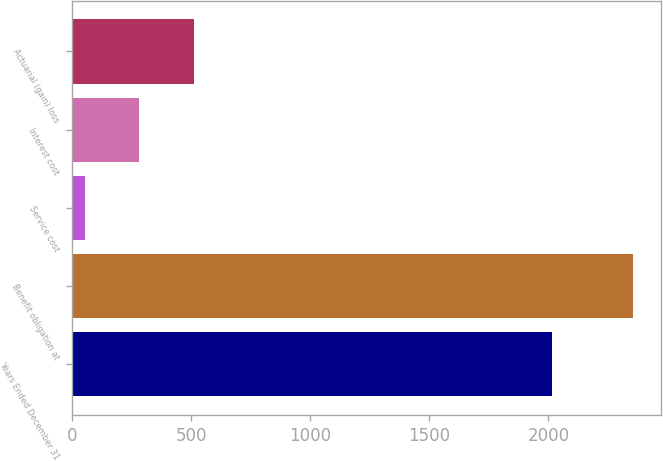Convert chart to OTSL. <chart><loc_0><loc_0><loc_500><loc_500><bar_chart><fcel>Years Ended December 31<fcel>Benefit obligation at<fcel>Service cost<fcel>Interest cost<fcel>Actuarial (gain) loss<nl><fcel>2013<fcel>2354<fcel>53<fcel>283.1<fcel>513.2<nl></chart> 